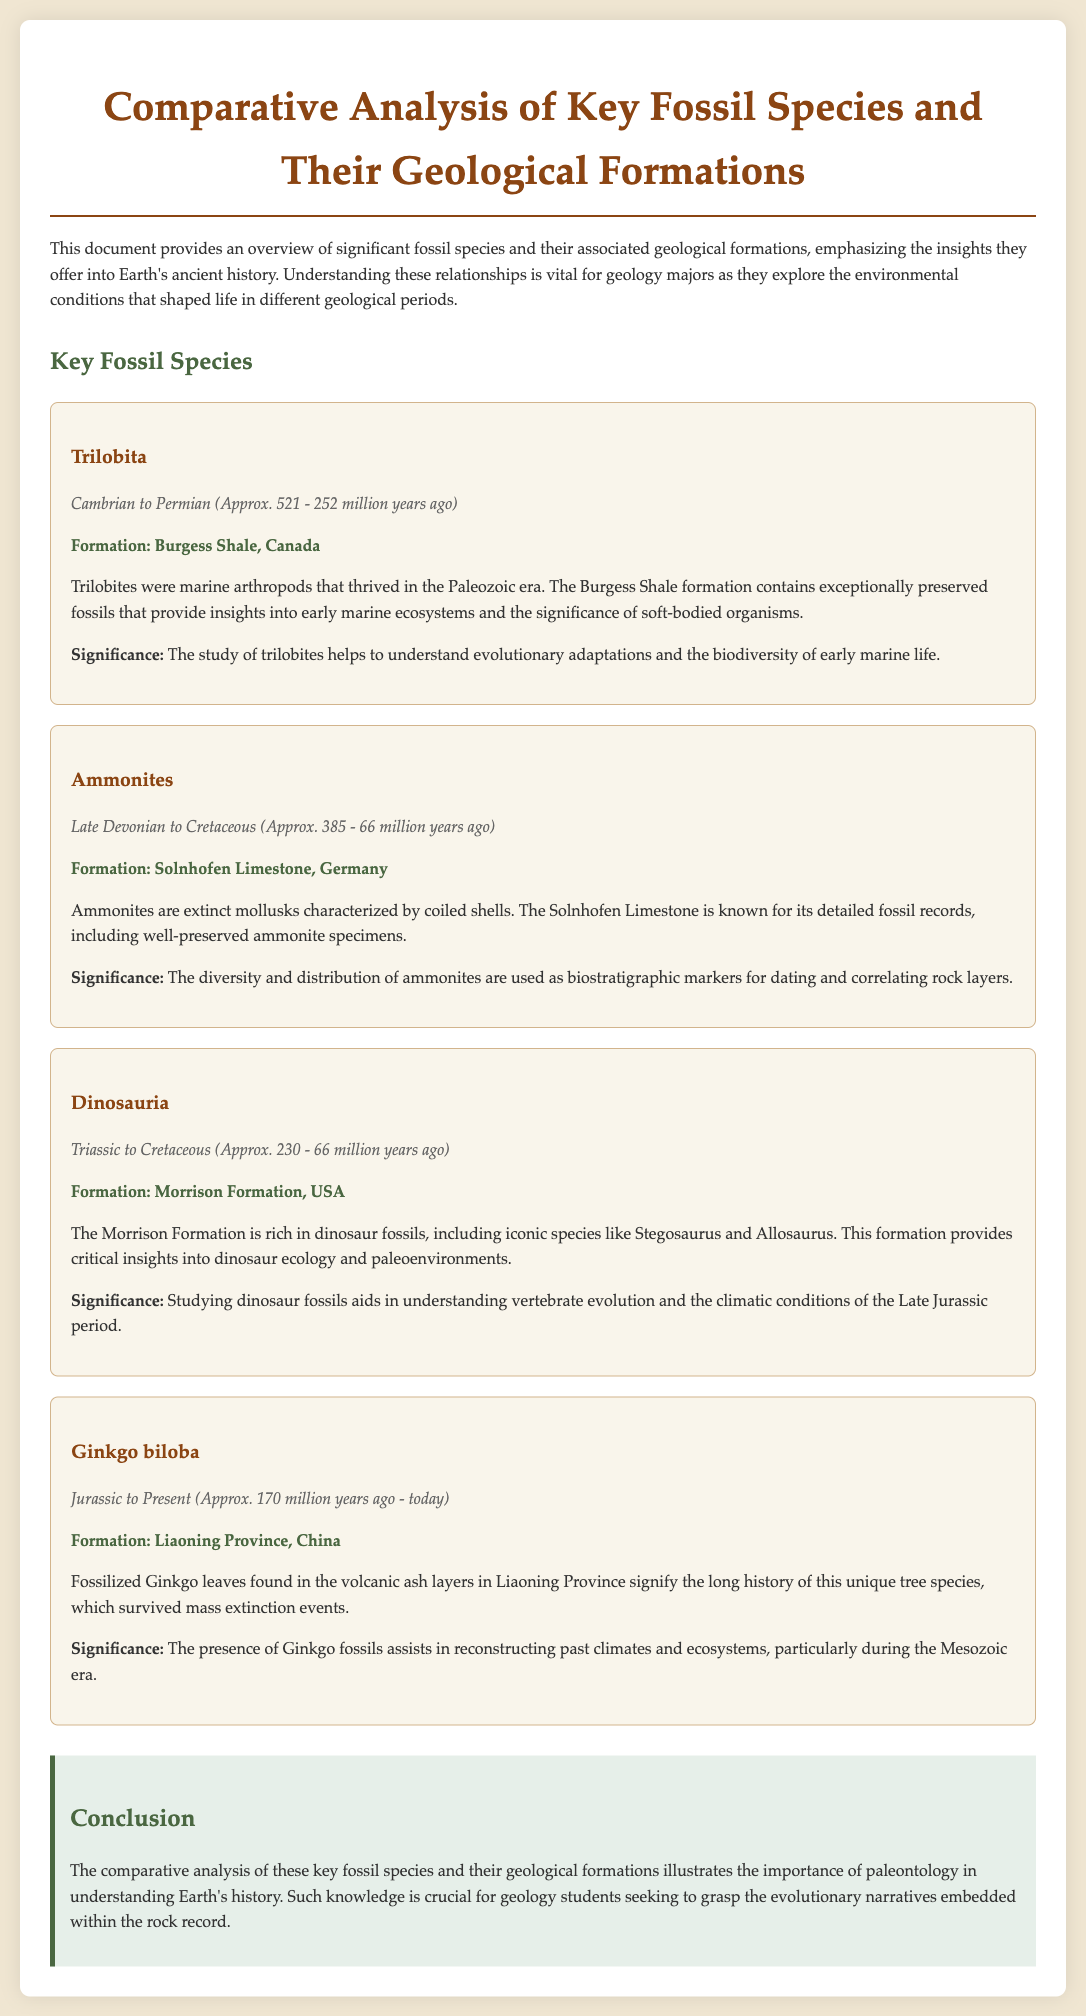What time period did Trilobita exist? The time period is mentioned in the document as Cambrian to Permian, which covers approximately 521 to 252 million years ago.
Answer: Cambrian to Permian (Approx. 521 - 252 million years ago) What is the significance of Ammonites? The significance is explained as their diversity and distribution being used as biostratigraphic markers for dating and correlating rock layers.
Answer: Biostratigraphic markers What geological formation is associated with Dinosauria? The document specifies that the Morrison Formation in the USA is associated with Dinosauria fossils.
Answer: Morrison Formation, USA How long has Ginkgo biloba existed? According to the text, Ginkgo biloba has existed from the Jurassic to the present, specifically for about 170 million years ago to today.
Answer: Jurassic to Present (Approx. 170 million years ago - today) What notable species are found in the Morrison Formation? The document notes iconic species like Stegosaurus and Allosaurus found in the Morrison Formation.
Answer: Stegosaurus and Allosaurus What do the fossils in the Burgess Shale provide insights about? The fossils give insights into early marine ecosystems and the significance of soft-bodied organisms, as described in the document.
Answer: Early marine ecosystems Which formation is known for detailed fossil records of ammonites? The document mentions Solnhofen Limestone in Germany as known for detailed records including ammonites.
Answer: Solnhofen Limestone, Germany What does the study of trilobites help understand? The document states that studying trilobites helps to understand evolutionary adaptations and the biodiversity of early marine life.
Answer: Evolutionary adaptations and biodiversity What type of analysis is emphasized for geology majors in the conclusion? The conclusion emphasizes the importance of comparative analysis of key fossil species and geological formations for understanding Earth's history.
Answer: Comparative analysis 